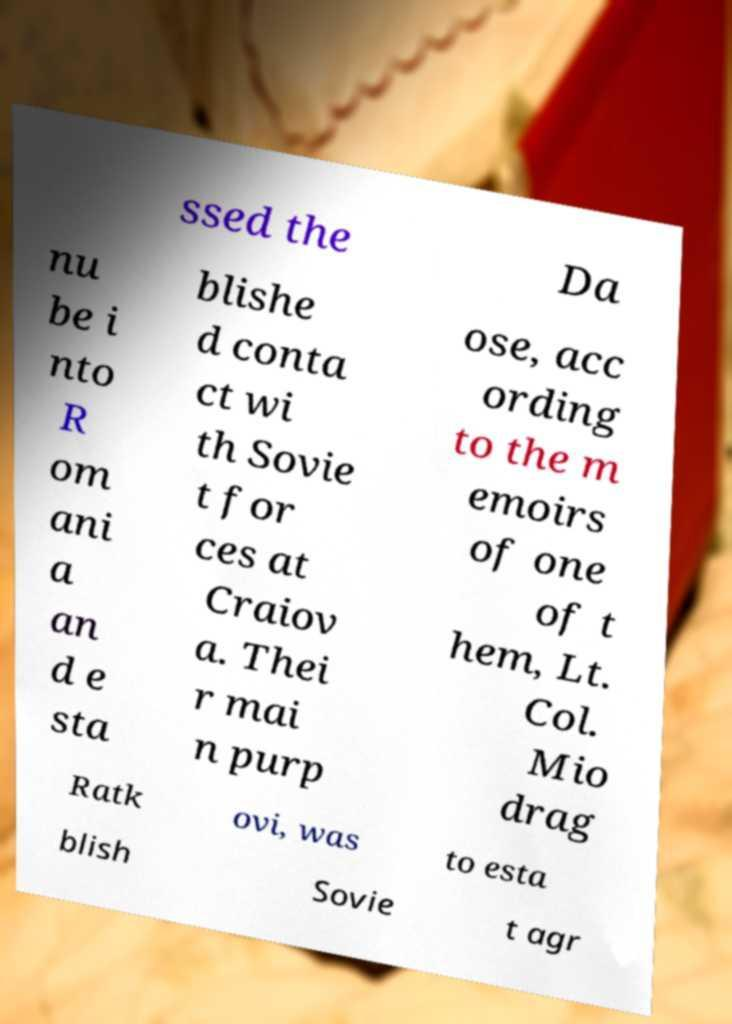For documentation purposes, I need the text within this image transcribed. Could you provide that? ssed the Da nu be i nto R om ani a an d e sta blishe d conta ct wi th Sovie t for ces at Craiov a. Thei r mai n purp ose, acc ording to the m emoirs of one of t hem, Lt. Col. Mio drag Ratk ovi, was to esta blish Sovie t agr 